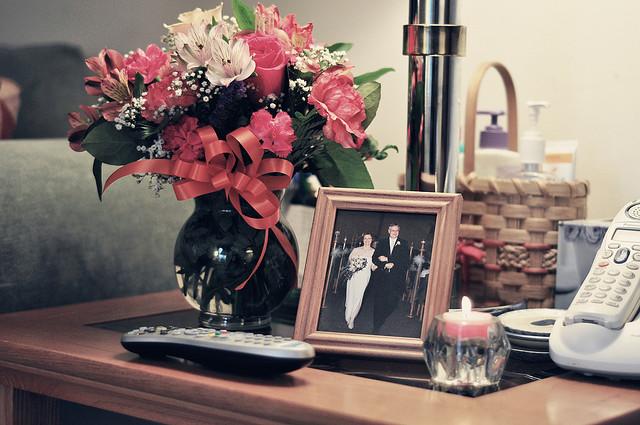Who is in the framed photograph?
Write a very short answer. Couple. Is there any water in the vase?
Be succinct. Yes. What is the item in the front of the picture?
Write a very short answer. Remote. 